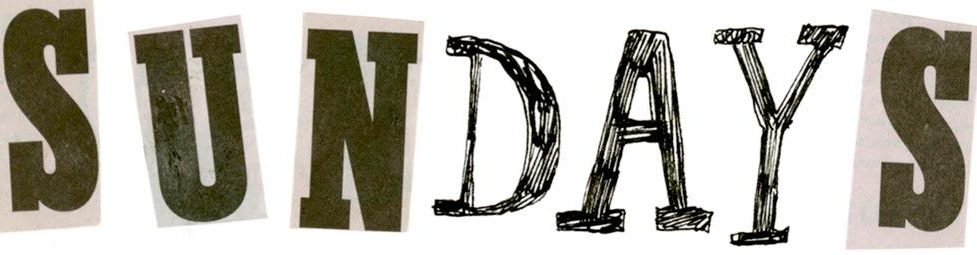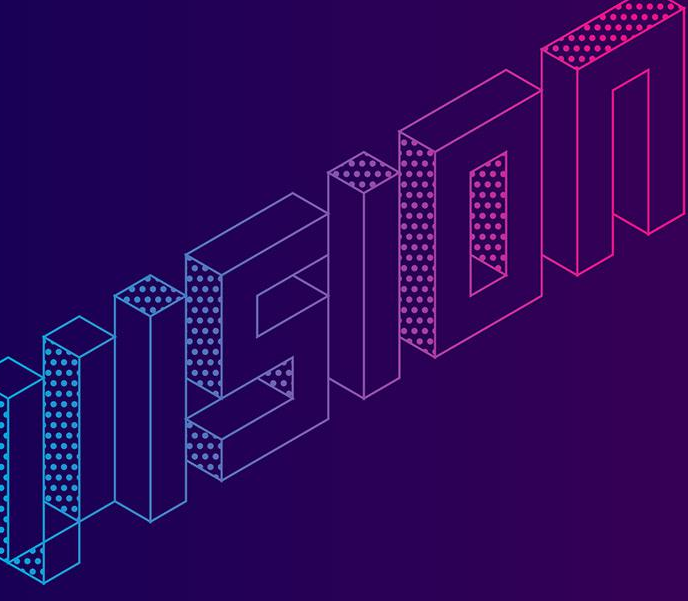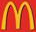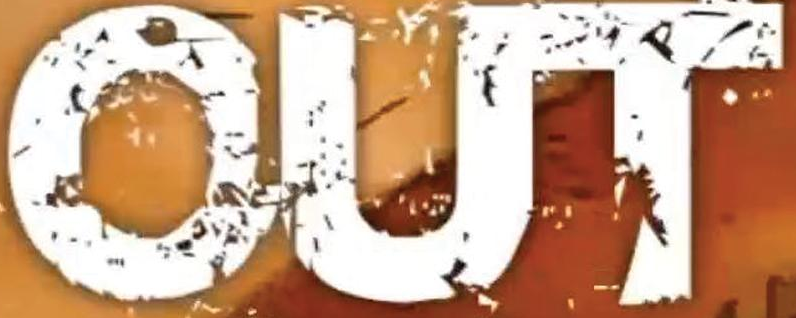What words are shown in these images in order, separated by a semicolon? SUNDAYS; VISION; m; OUT 